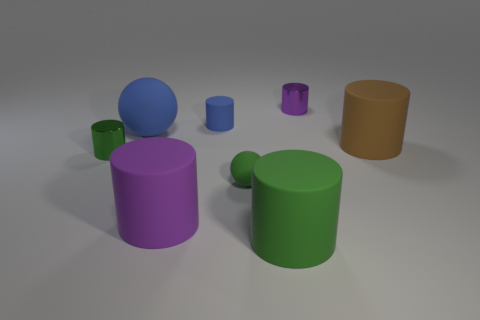Are there fewer large rubber objects than cyan metal blocks?
Make the answer very short. No. What number of other things are the same color as the large sphere?
Provide a succinct answer. 1. Are the large thing in front of the large purple matte thing and the blue cylinder made of the same material?
Your answer should be compact. Yes. There is a purple thing left of the tiny blue object; what is its material?
Provide a short and direct response. Rubber. There is a matte thing in front of the purple thing in front of the large blue object; what size is it?
Offer a terse response. Large. Is there a cyan block that has the same material as the blue ball?
Keep it short and to the point. No. There is a large matte thing behind the large thing on the right side of the tiny thing to the right of the small rubber sphere; what is its shape?
Offer a terse response. Sphere. There is a tiny shiny object that is to the right of the large green rubber cylinder; is it the same color as the rubber ball right of the large blue thing?
Give a very brief answer. No. Is there anything else that is the same size as the brown cylinder?
Your answer should be compact. Yes. There is a tiny blue thing; are there any blue things in front of it?
Offer a very short reply. Yes. 